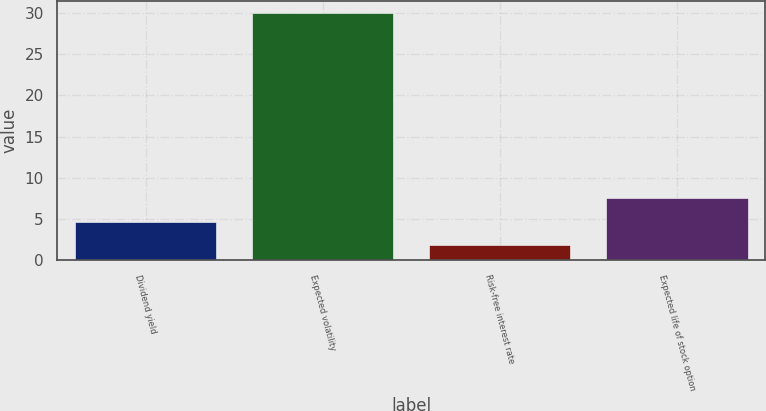Convert chart to OTSL. <chart><loc_0><loc_0><loc_500><loc_500><bar_chart><fcel>Dividend yield<fcel>Expected volatility<fcel>Risk-free interest rate<fcel>Expected life of stock option<nl><fcel>4.71<fcel>30<fcel>1.9<fcel>7.52<nl></chart> 